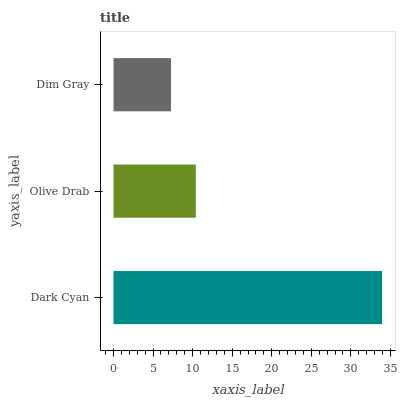Is Dim Gray the minimum?
Answer yes or no. Yes. Is Dark Cyan the maximum?
Answer yes or no. Yes. Is Olive Drab the minimum?
Answer yes or no. No. Is Olive Drab the maximum?
Answer yes or no. No. Is Dark Cyan greater than Olive Drab?
Answer yes or no. Yes. Is Olive Drab less than Dark Cyan?
Answer yes or no. Yes. Is Olive Drab greater than Dark Cyan?
Answer yes or no. No. Is Dark Cyan less than Olive Drab?
Answer yes or no. No. Is Olive Drab the high median?
Answer yes or no. Yes. Is Olive Drab the low median?
Answer yes or no. Yes. Is Dim Gray the high median?
Answer yes or no. No. Is Dim Gray the low median?
Answer yes or no. No. 